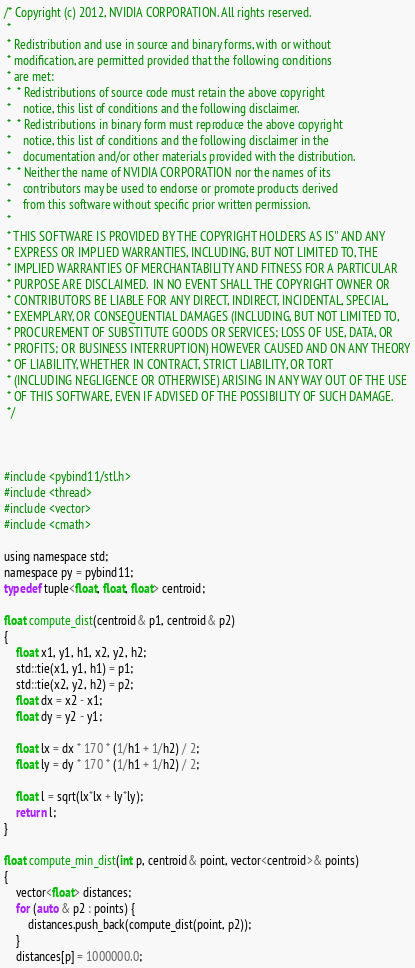<code> <loc_0><loc_0><loc_500><loc_500><_Cuda_>
/* Copyright (c) 2012, NVIDIA CORPORATION. All rights reserved.
 *
 * Redistribution and use in source and binary forms, with or without
 * modification, are permitted provided that the following conditions
 * are met:
 *  * Redistributions of source code must retain the above copyright
 *    notice, this list of conditions and the following disclaimer.
 *  * Redistributions in binary form must reproduce the above copyright
 *    notice, this list of conditions and the following disclaimer in the
 *    documentation and/or other materials provided with the distribution.
 *  * Neither the name of NVIDIA CORPORATION nor the names of its
 *    contributors may be used to endorse or promote products derived
 *    from this software without specific prior written permission.
 *
 * THIS SOFTWARE IS PROVIDED BY THE COPYRIGHT HOLDERS AS IS'' AND ANY
 * EXPRESS OR IMPLIED WARRANTIES, INCLUDING, BUT NOT LIMITED TO, THE
 * IMPLIED WARRANTIES OF MERCHANTABILITY AND FITNESS FOR A PARTICULAR
 * PURPOSE ARE DISCLAIMED.  IN NO EVENT SHALL THE COPYRIGHT OWNER OR
 * CONTRIBUTORS BE LIABLE FOR ANY DIRECT, INDIRECT, INCIDENTAL, SPECIAL,
 * EXEMPLARY, OR CONSEQUENTIAL DAMAGES (INCLUDING, BUT NOT LIMITED TO,
 * PROCUREMENT OF SUBSTITUTE GOODS OR SERVICES; LOSS OF USE, DATA, OR
 * PROFITS; OR BUSINESS INTERRUPTION) HOWEVER CAUSED AND ON ANY THEORY
 * OF LIABILITY, WHETHER IN CONTRACT, STRICT LIABILITY, OR TORT
 * (INCLUDING NEGLIGENCE OR OTHERWISE) ARISING IN ANY WAY OUT OF THE USE
 * OF THIS SOFTWARE, EVEN IF ADVISED OF THE POSSIBILITY OF SUCH DAMAGE.
 */



#include <pybind11/stl.h>
#include <thread>
#include <vector>
#include <cmath>

using namespace std;
namespace py = pybind11;
typedef tuple<float, float, float> centroid;

float compute_dist(centroid& p1, centroid& p2)
{
    float x1, y1, h1, x2, y2, h2;
    std::tie(x1, y1, h1) = p1;
    std::tie(x2, y2, h2) = p2;
    float dx = x2 - x1;
    float dy = y2 - y1;

    float lx = dx * 170 * (1/h1 + 1/h2) / 2;
    float ly = dy * 170 * (1/h1 + 1/h2) / 2;

    float l = sqrt(lx*lx + ly*ly);
    return l;
}

float compute_min_dist(int p, centroid& point, vector<centroid>& points) 
{
    vector<float> distances;
    for (auto & p2 : points) {
        distances.push_back(compute_dist(point, p2));
    }
    distances[p] = 1000000.0;</code> 